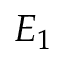<formula> <loc_0><loc_0><loc_500><loc_500>E _ { 1 }</formula> 